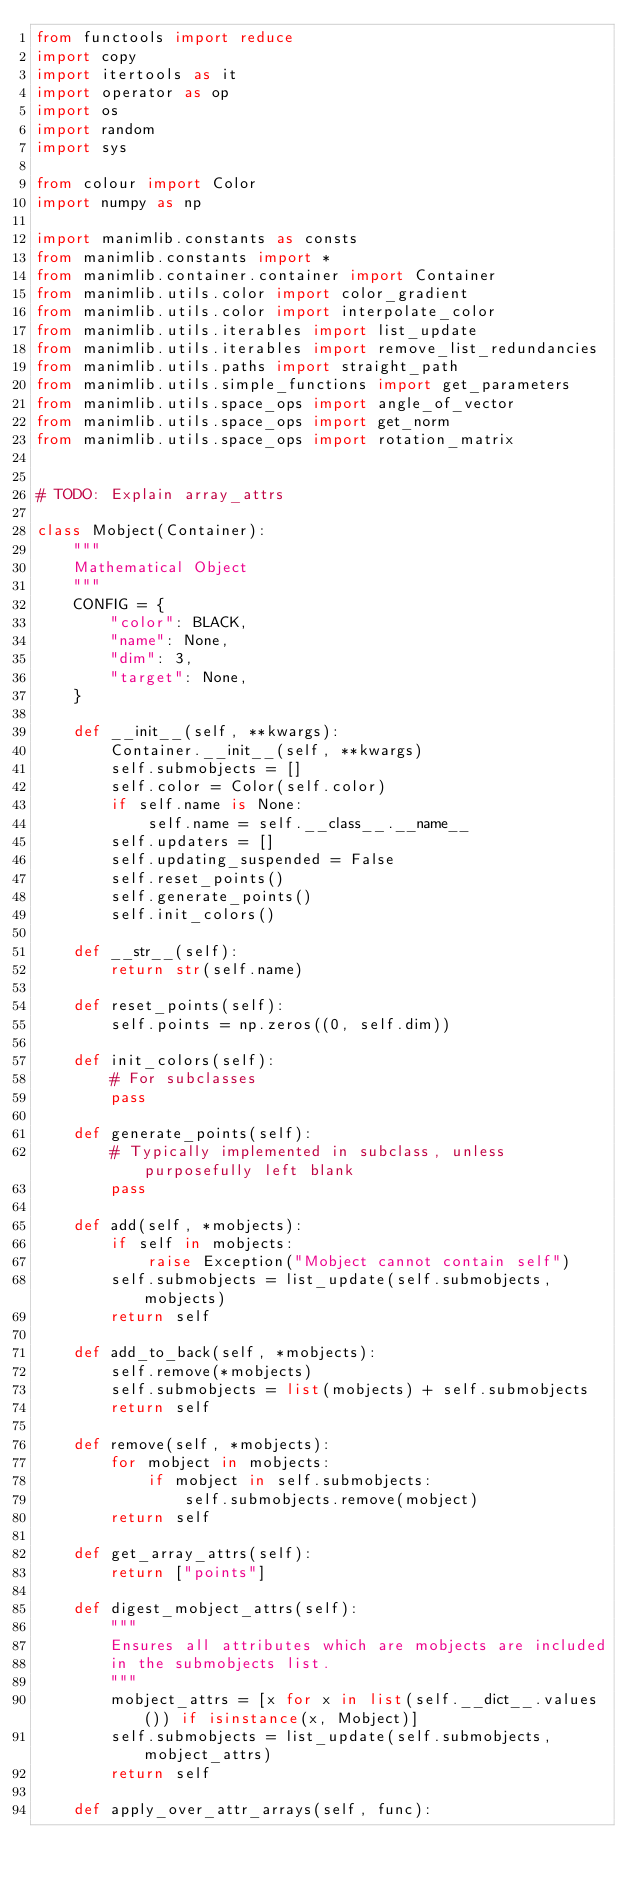Convert code to text. <code><loc_0><loc_0><loc_500><loc_500><_Python_>from functools import reduce
import copy
import itertools as it
import operator as op
import os
import random
import sys

from colour import Color
import numpy as np

import manimlib.constants as consts
from manimlib.constants import *
from manimlib.container.container import Container
from manimlib.utils.color import color_gradient
from manimlib.utils.color import interpolate_color
from manimlib.utils.iterables import list_update
from manimlib.utils.iterables import remove_list_redundancies
from manimlib.utils.paths import straight_path
from manimlib.utils.simple_functions import get_parameters
from manimlib.utils.space_ops import angle_of_vector
from manimlib.utils.space_ops import get_norm
from manimlib.utils.space_ops import rotation_matrix


# TODO: Explain array_attrs

class Mobject(Container):
    """
    Mathematical Object
    """
    CONFIG = {
        "color": BLACK,
        "name": None,
        "dim": 3,
        "target": None,
    }

    def __init__(self, **kwargs):
        Container.__init__(self, **kwargs)
        self.submobjects = []
        self.color = Color(self.color)
        if self.name is None:
            self.name = self.__class__.__name__
        self.updaters = []
        self.updating_suspended = False
        self.reset_points()
        self.generate_points()
        self.init_colors()

    def __str__(self):
        return str(self.name)

    def reset_points(self):
        self.points = np.zeros((0, self.dim))

    def init_colors(self):
        # For subclasses
        pass

    def generate_points(self):
        # Typically implemented in subclass, unless purposefully left blank
        pass

    def add(self, *mobjects):
        if self in mobjects:
            raise Exception("Mobject cannot contain self")
        self.submobjects = list_update(self.submobjects, mobjects)
        return self

    def add_to_back(self, *mobjects):
        self.remove(*mobjects)
        self.submobjects = list(mobjects) + self.submobjects
        return self

    def remove(self, *mobjects):
        for mobject in mobjects:
            if mobject in self.submobjects:
                self.submobjects.remove(mobject)
        return self

    def get_array_attrs(self):
        return ["points"]

    def digest_mobject_attrs(self):
        """
        Ensures all attributes which are mobjects are included
        in the submobjects list.
        """
        mobject_attrs = [x for x in list(self.__dict__.values()) if isinstance(x, Mobject)]
        self.submobjects = list_update(self.submobjects, mobject_attrs)
        return self

    def apply_over_attr_arrays(self, func):</code> 